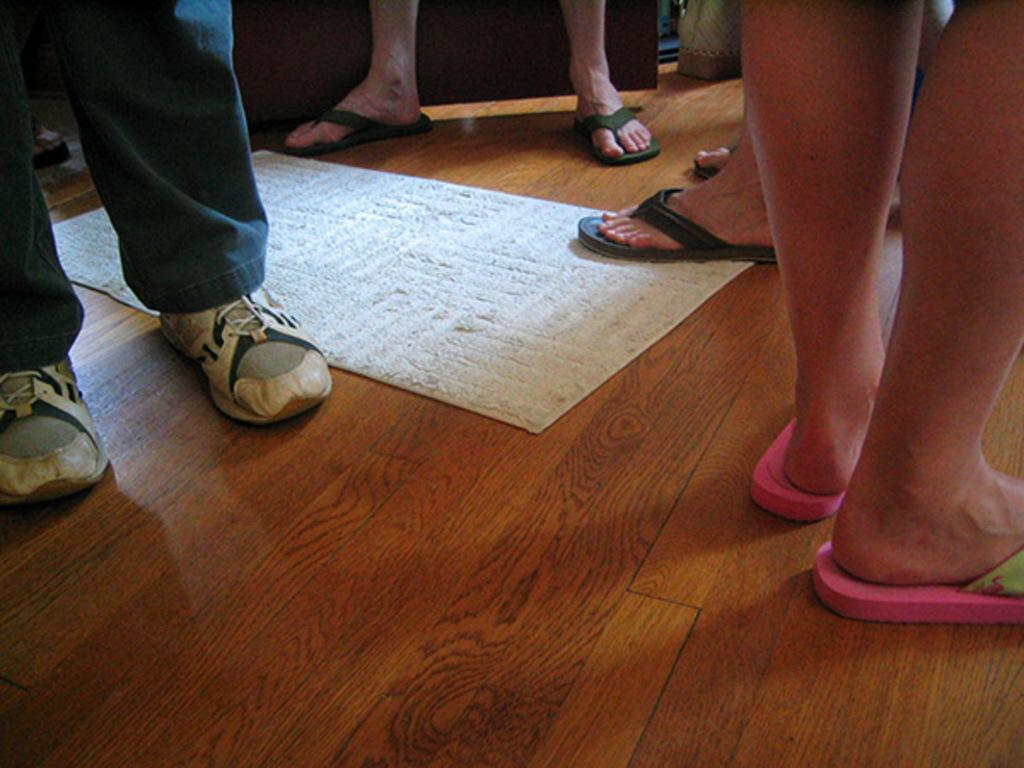What can be seen at the bottom of the image? There is a floor in the image. What is placed on the floor? There is a mat in the image. Can you describe any body parts visible in the image? Yes, there are legs of a few persons visible in the image. What type of guide is sitting on the sofa in the image? There is no guide or sofa present in the image. What reward is being given to the person in the image? There is no reward being given in the image; it only shows legs of a few persons, a floor, and a mat. 